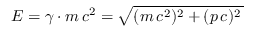Convert formula to latex. <formula><loc_0><loc_0><loc_500><loc_500>E = \gamma \cdot m \, c ^ { 2 } = \sqrt { ( m \, c ^ { 2 } ) ^ { 2 } + ( p \, c ) ^ { 2 } \, }</formula> 